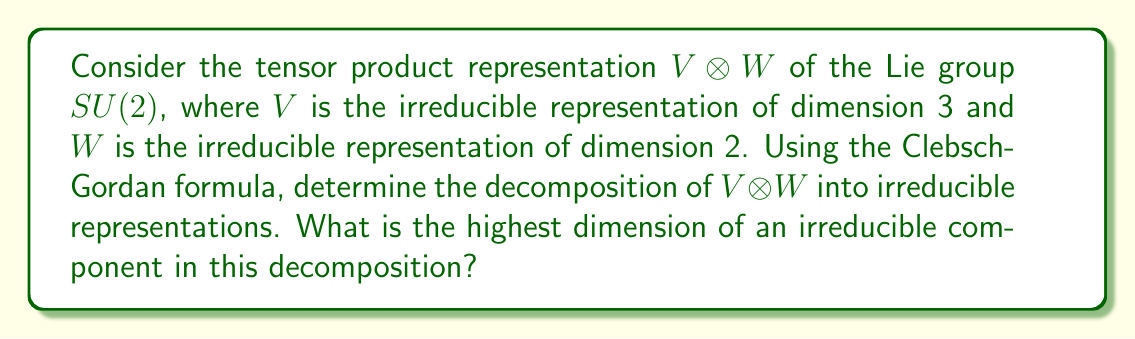Show me your answer to this math problem. To solve this problem, we'll follow these steps:

1) First, recall that for $SU(2)$, irreducible representations are labeled by their dimension, which is always odd for $SU(2)$. The dimension is related to the highest weight $j$ by the formula $\text{dim} = 2j + 1$.

2) In this case, we have:
   $V$: dimension 3, so $j_1 = 1$
   $W$: dimension 2, so $j_2 = 1/2$

3) The Clebsch-Gordan formula states that:

   $$V_{j_1} \otimes V_{j_2} = \bigoplus_{j=|j_1-j_2|}^{j_1+j_2} V_j$$

   Where the sum is taken over integer steps.

4) Applying this to our case:

   $$V_1 \otimes V_{1/2} = \bigoplus_{j=|1-1/2|}^{1+1/2} V_j = V_{1/2} \oplus V_{3/2}$$

5) To get the dimensions, we use $\text{dim} = 2j + 1$:
   
   $V_{1/2}$: dimension $2(1/2) + 1 = 2$
   $V_{3/2}$: dimension $2(3/2) + 1 = 4$

6) Therefore, the decomposition is:

   $$V \otimes W \cong V_2 \oplus V_4$$

   Where the subscripts denote the dimensions of the irreducible representations.

7) The highest dimension in this decomposition is 4.
Answer: 4 